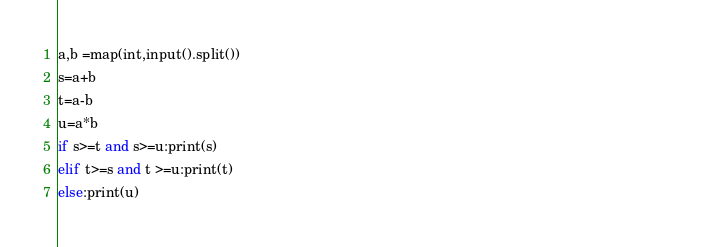Convert code to text. <code><loc_0><loc_0><loc_500><loc_500><_Python_>a,b =map(int,input().split())                                                                                                             
s=a+b       
t=a-b       
u=a*b       
if s>=t and s>=u:print(s)
elif t>=s and t >=u:print(t)
else:print(u)
</code> 